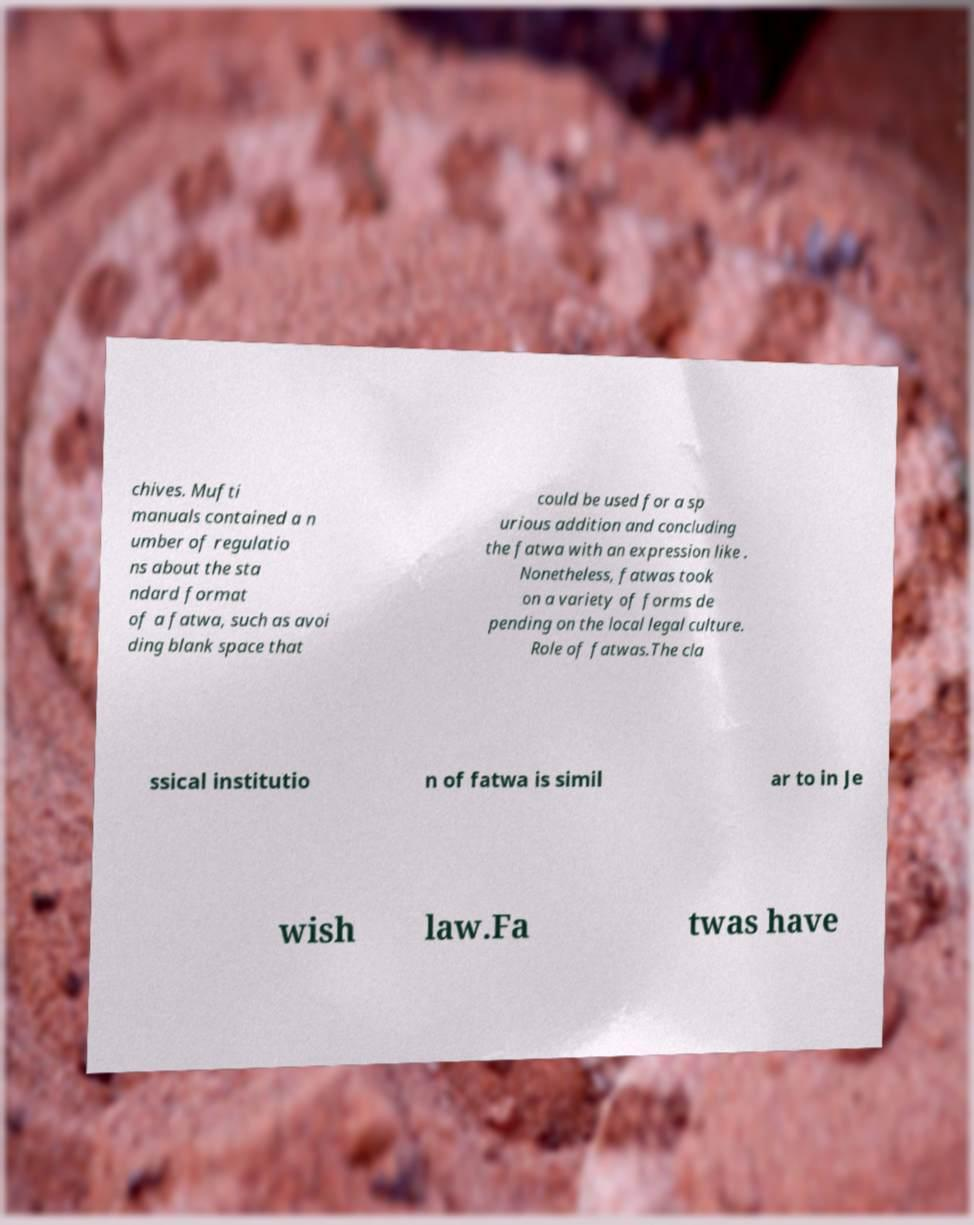What messages or text are displayed in this image? I need them in a readable, typed format. chives. Mufti manuals contained a n umber of regulatio ns about the sta ndard format of a fatwa, such as avoi ding blank space that could be used for a sp urious addition and concluding the fatwa with an expression like . Nonetheless, fatwas took on a variety of forms de pending on the local legal culture. Role of fatwas.The cla ssical institutio n of fatwa is simil ar to in Je wish law.Fa twas have 